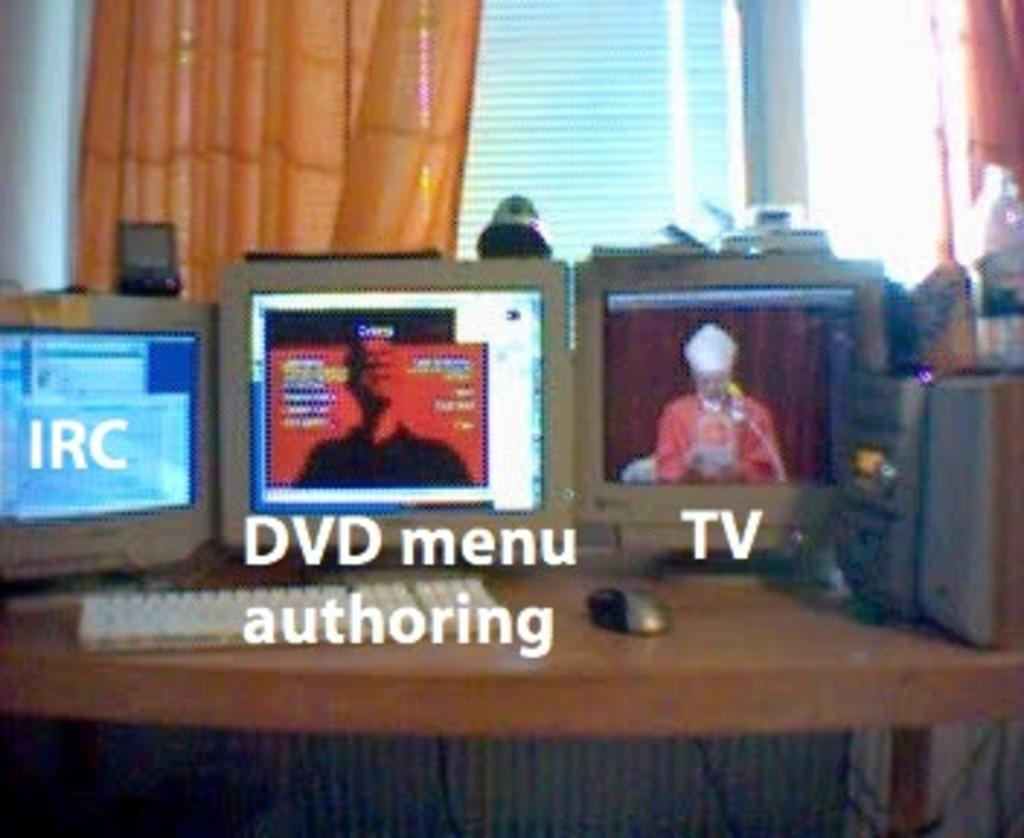What type of equipment is on the table in the image? There are monitors on a table in the image. What other device is visible in the image? There is a keyboard in the image. What is used for controlling the cursor on the monitors? There is a mouse in the image. What can be seen in the background of the image? There is a window visible in the background of the image. What flavor of baseball can be seen in the image? There is no baseball present in the image, and therefore no flavor can be associated with it. What type of amusement is depicted in the image? The image does not depict any amusement; it features monitors, a keyboard, a mouse, and a window. 